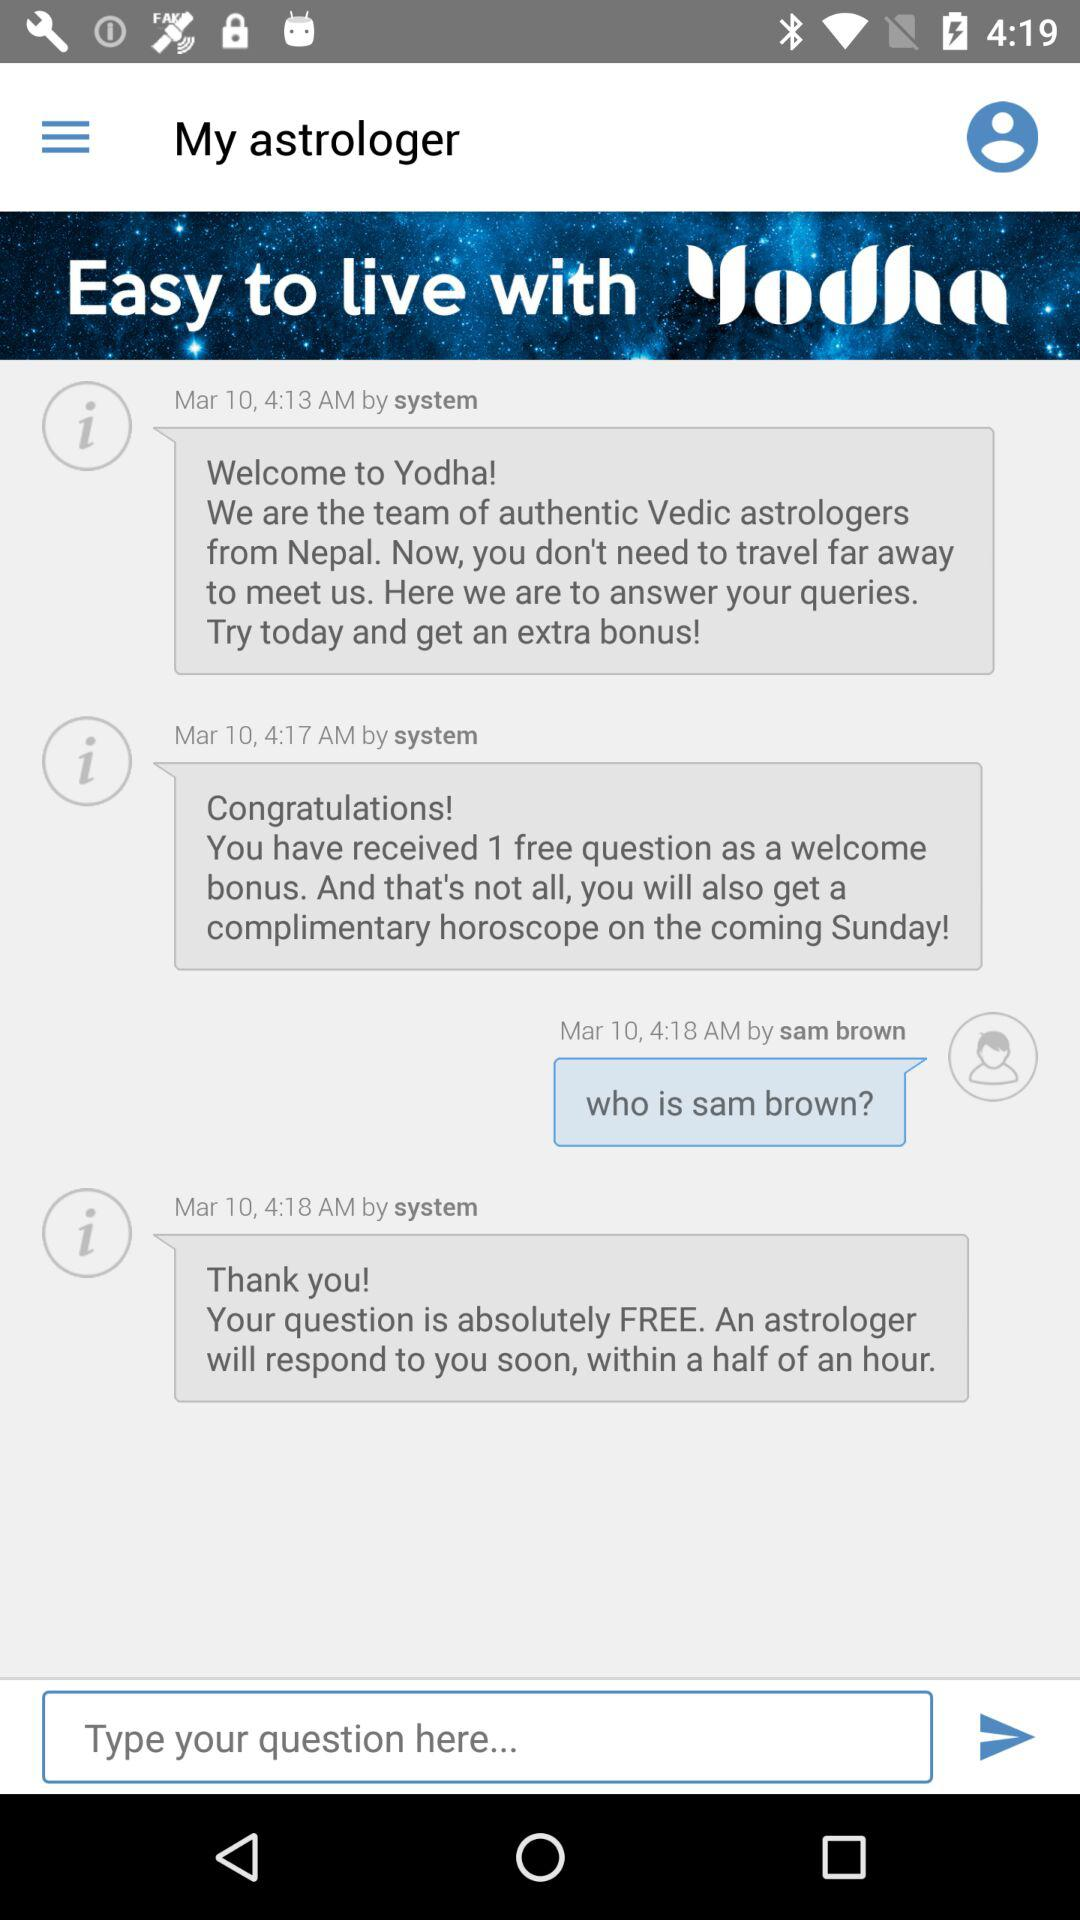What is the selected date? The selected date is Tuesday, February 13, 1990. 